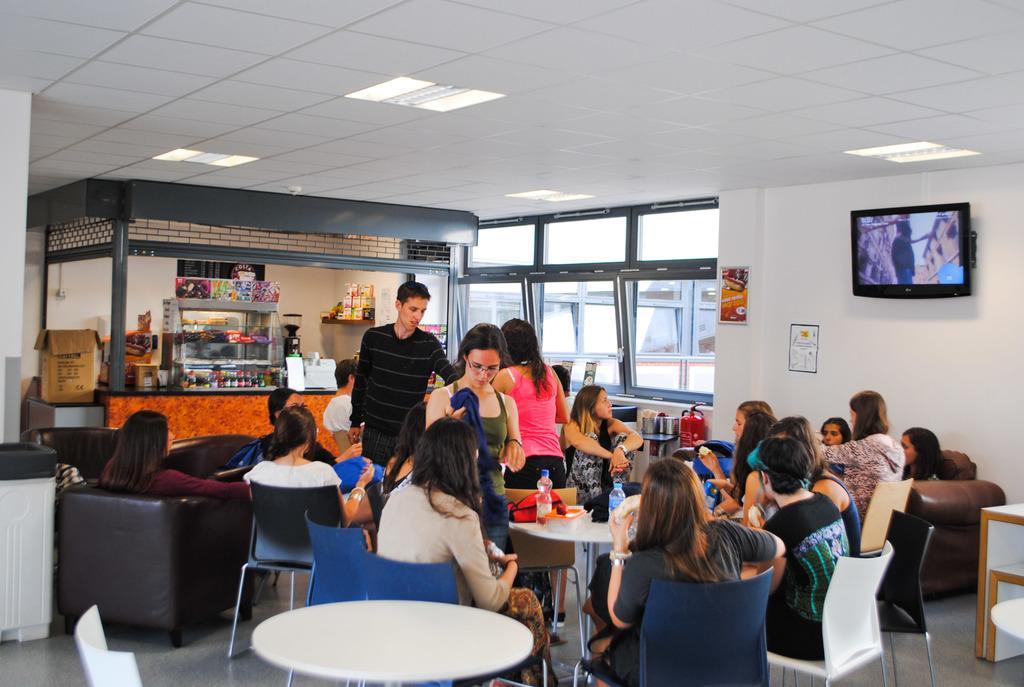Describe this image in one or two sentences. This is an image clicked inside the room. There are few people sitting on the chairs around the table. On the left side I can see a stall. There is a television is fixed on the right side wall. 